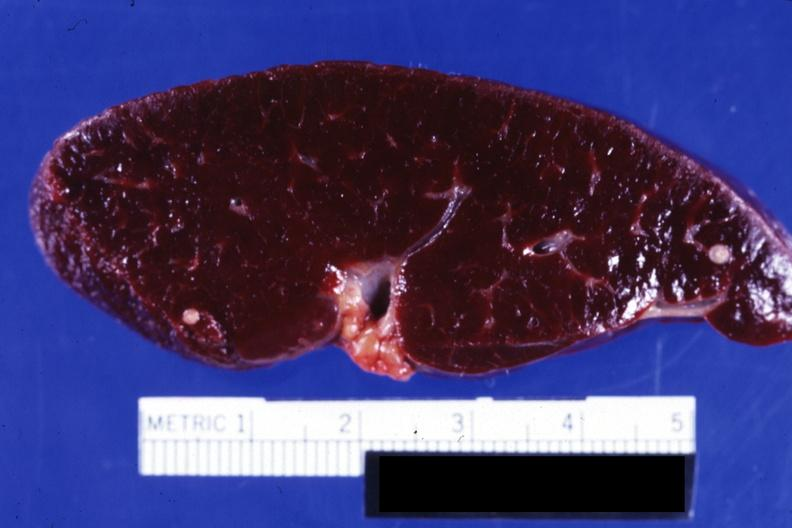s hematologic present?
Answer the question using a single word or phrase. Yes 